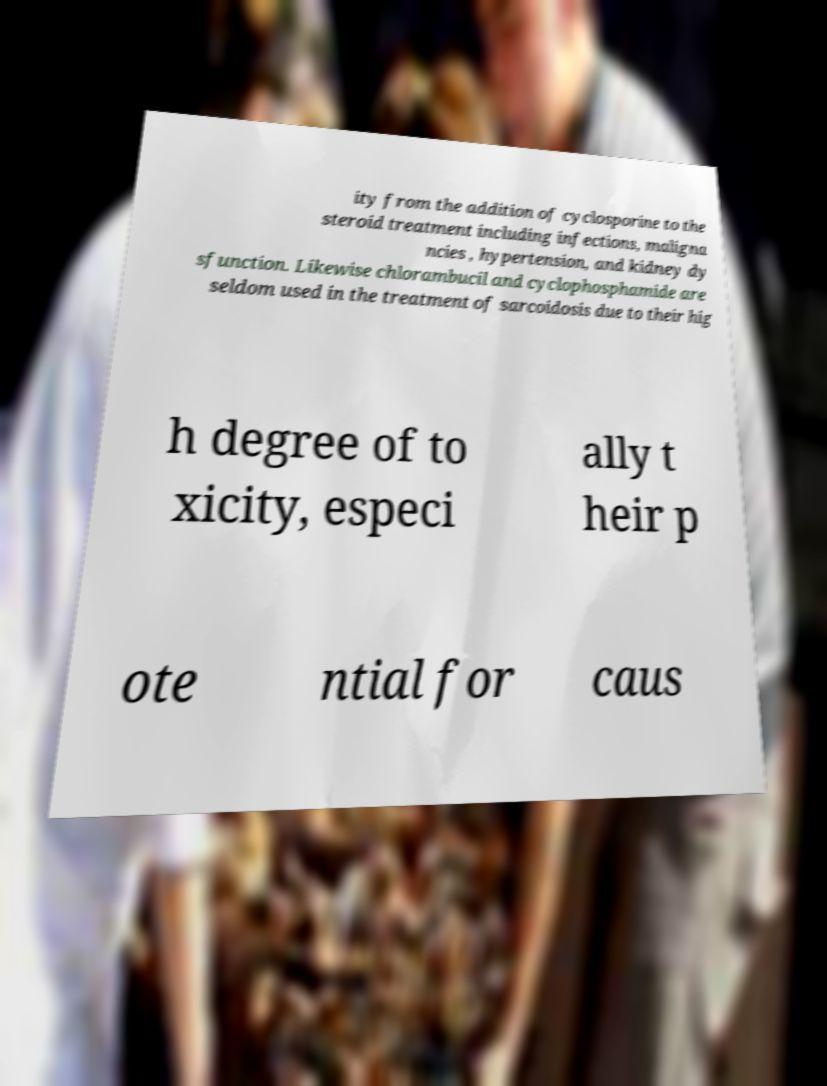What messages or text are displayed in this image? I need them in a readable, typed format. ity from the addition of cyclosporine to the steroid treatment including infections, maligna ncies , hypertension, and kidney dy sfunction. Likewise chlorambucil and cyclophosphamide are seldom used in the treatment of sarcoidosis due to their hig h degree of to xicity, especi ally t heir p ote ntial for caus 